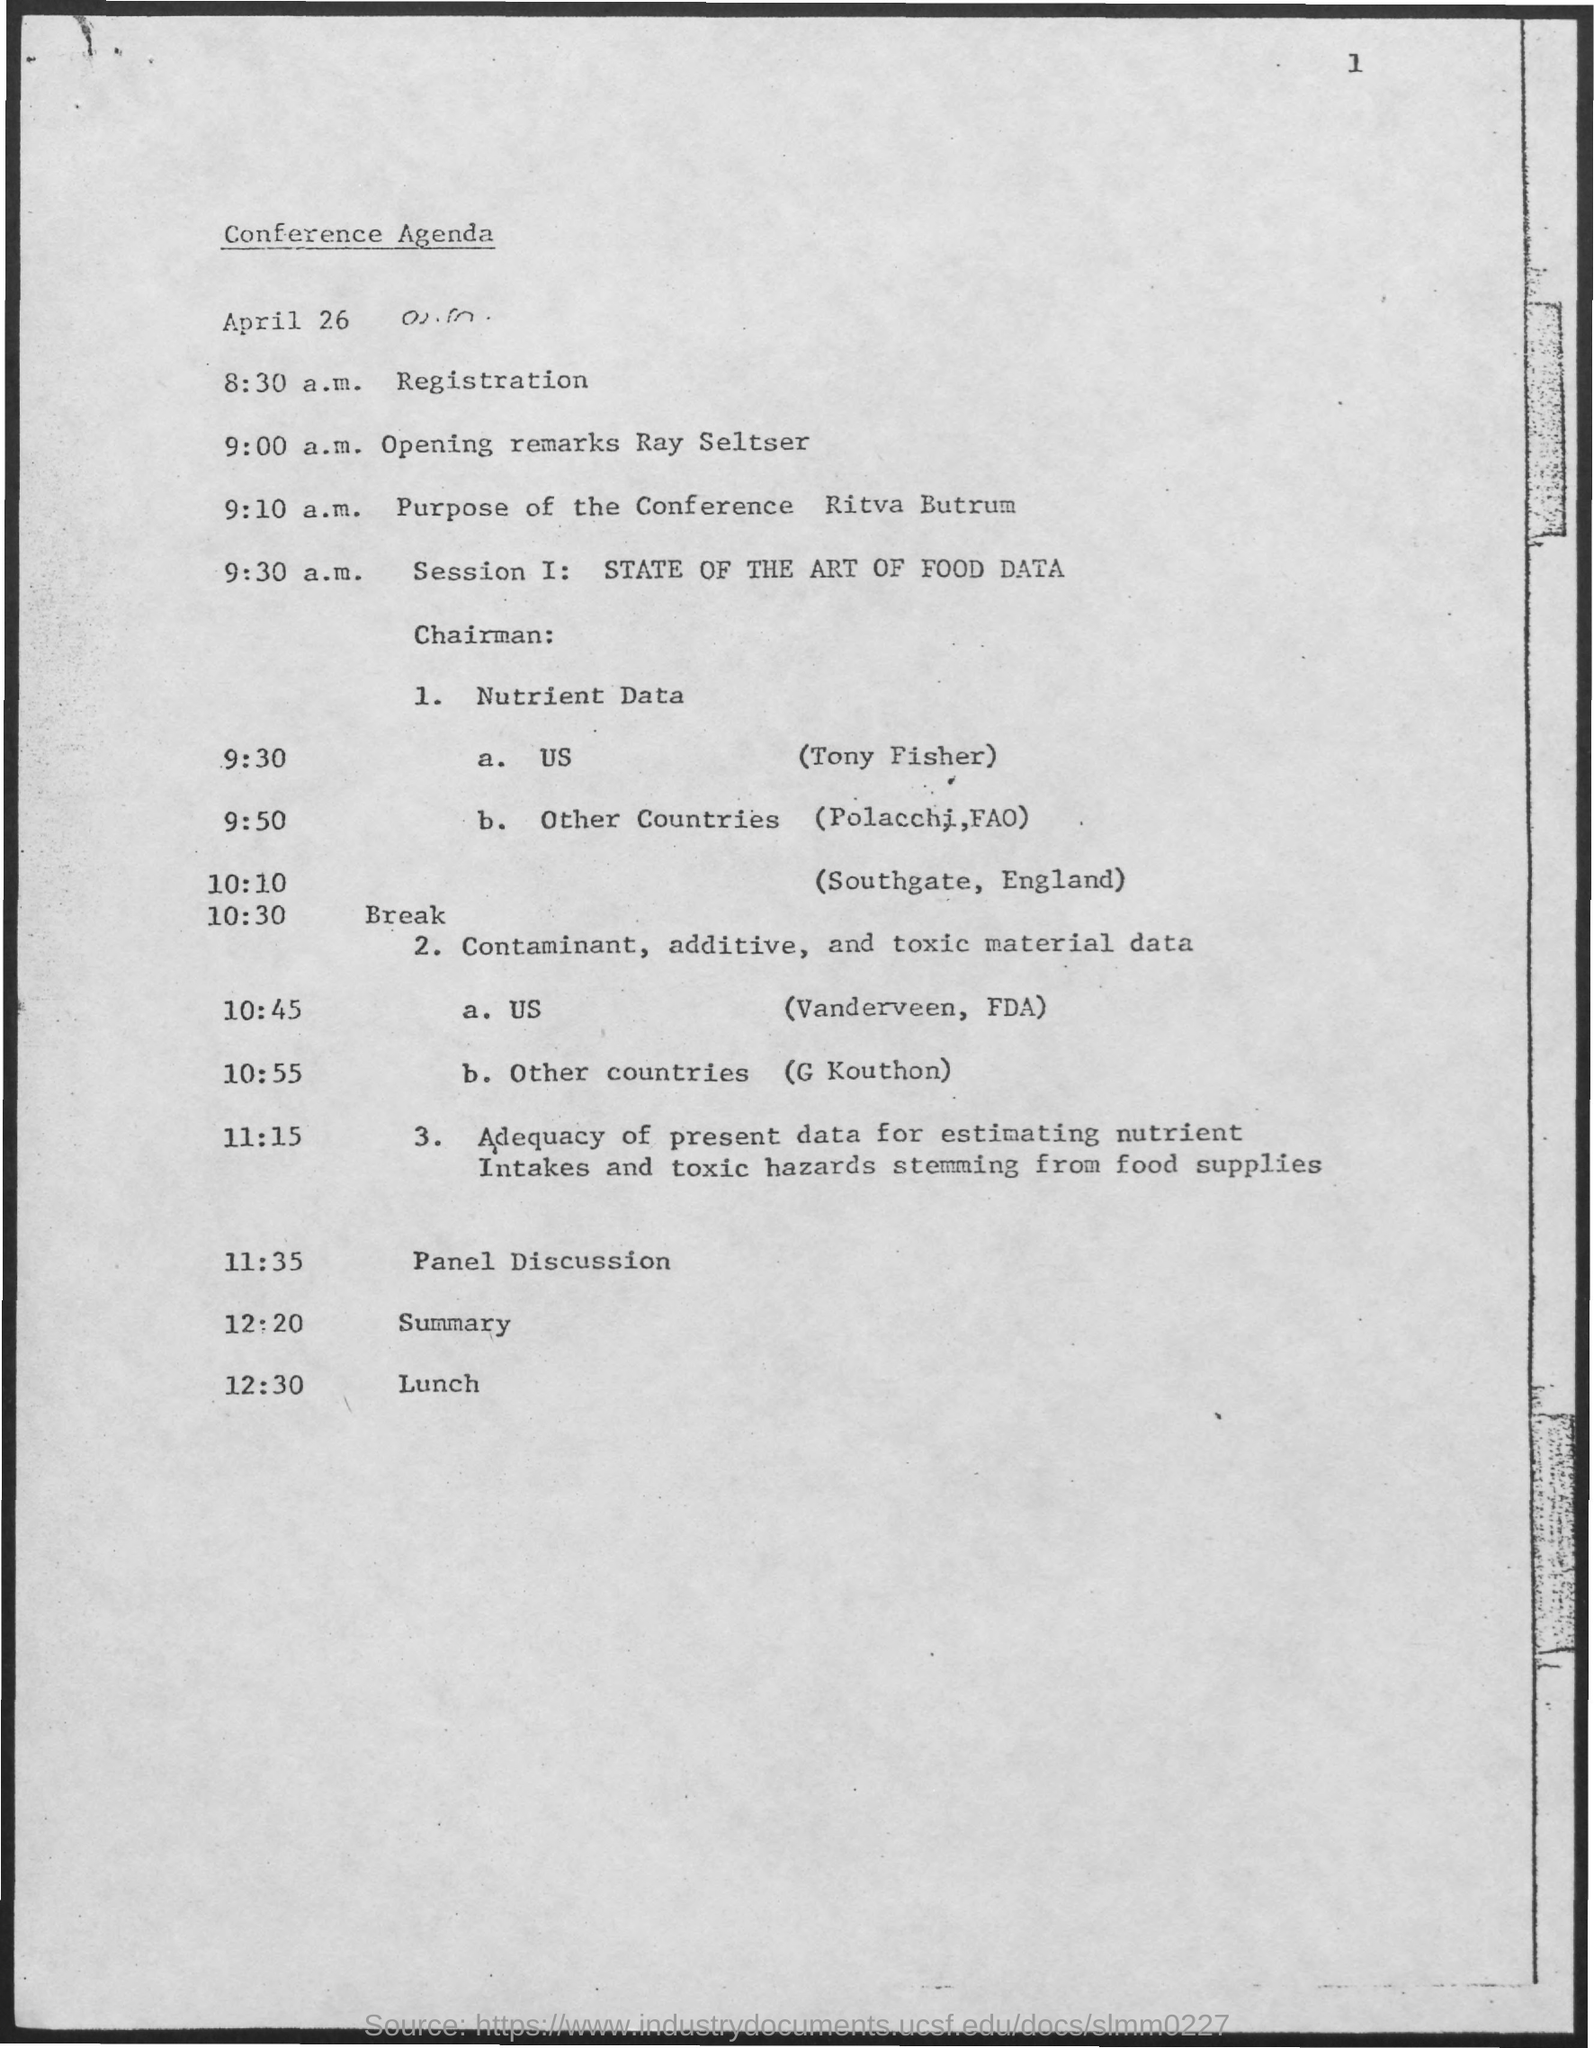Highlight a few significant elements in this photo. The first session will cover the state of the art of food data. Tony Fisher is from the United States. 